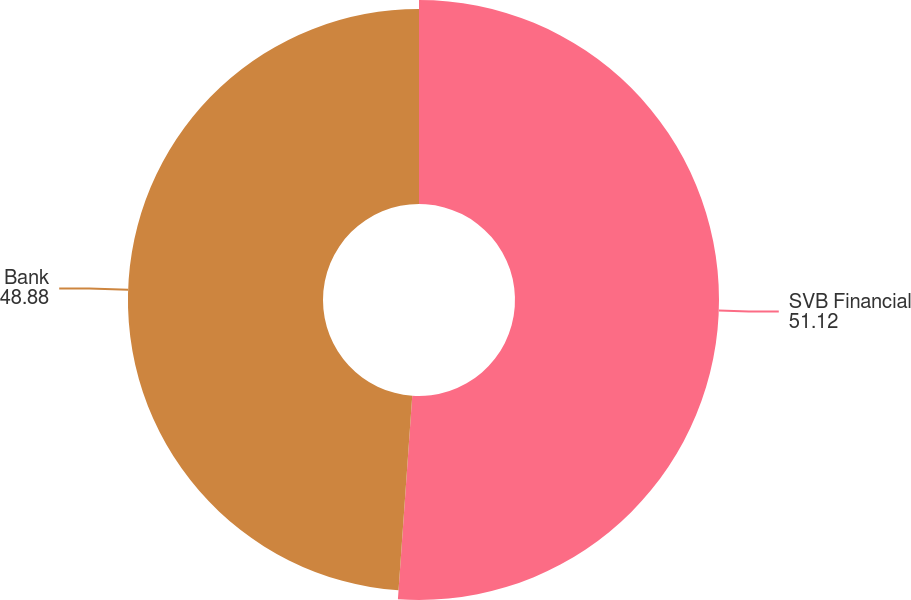Convert chart to OTSL. <chart><loc_0><loc_0><loc_500><loc_500><pie_chart><fcel>SVB Financial<fcel>Bank<nl><fcel>51.12%<fcel>48.88%<nl></chart> 